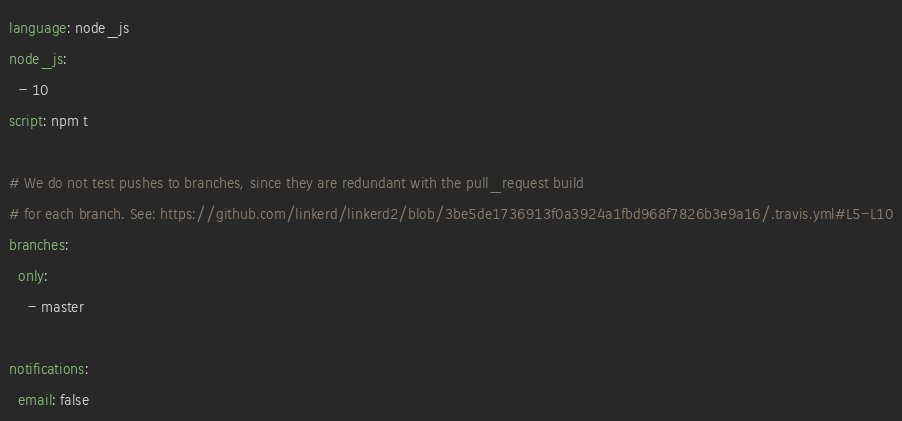Convert code to text. <code><loc_0><loc_0><loc_500><loc_500><_YAML_>language: node_js
node_js:
  - 10
script: npm t

# We do not test pushes to branches, since they are redundant with the pull_request build
# for each branch. See: https://github.com/linkerd/linkerd2/blob/3be5de1736913f0a3924a1fbd968f7826b3e9a16/.travis.yml#L5-L10
branches:
  only:
    - master

notifications:
  email: false
</code> 